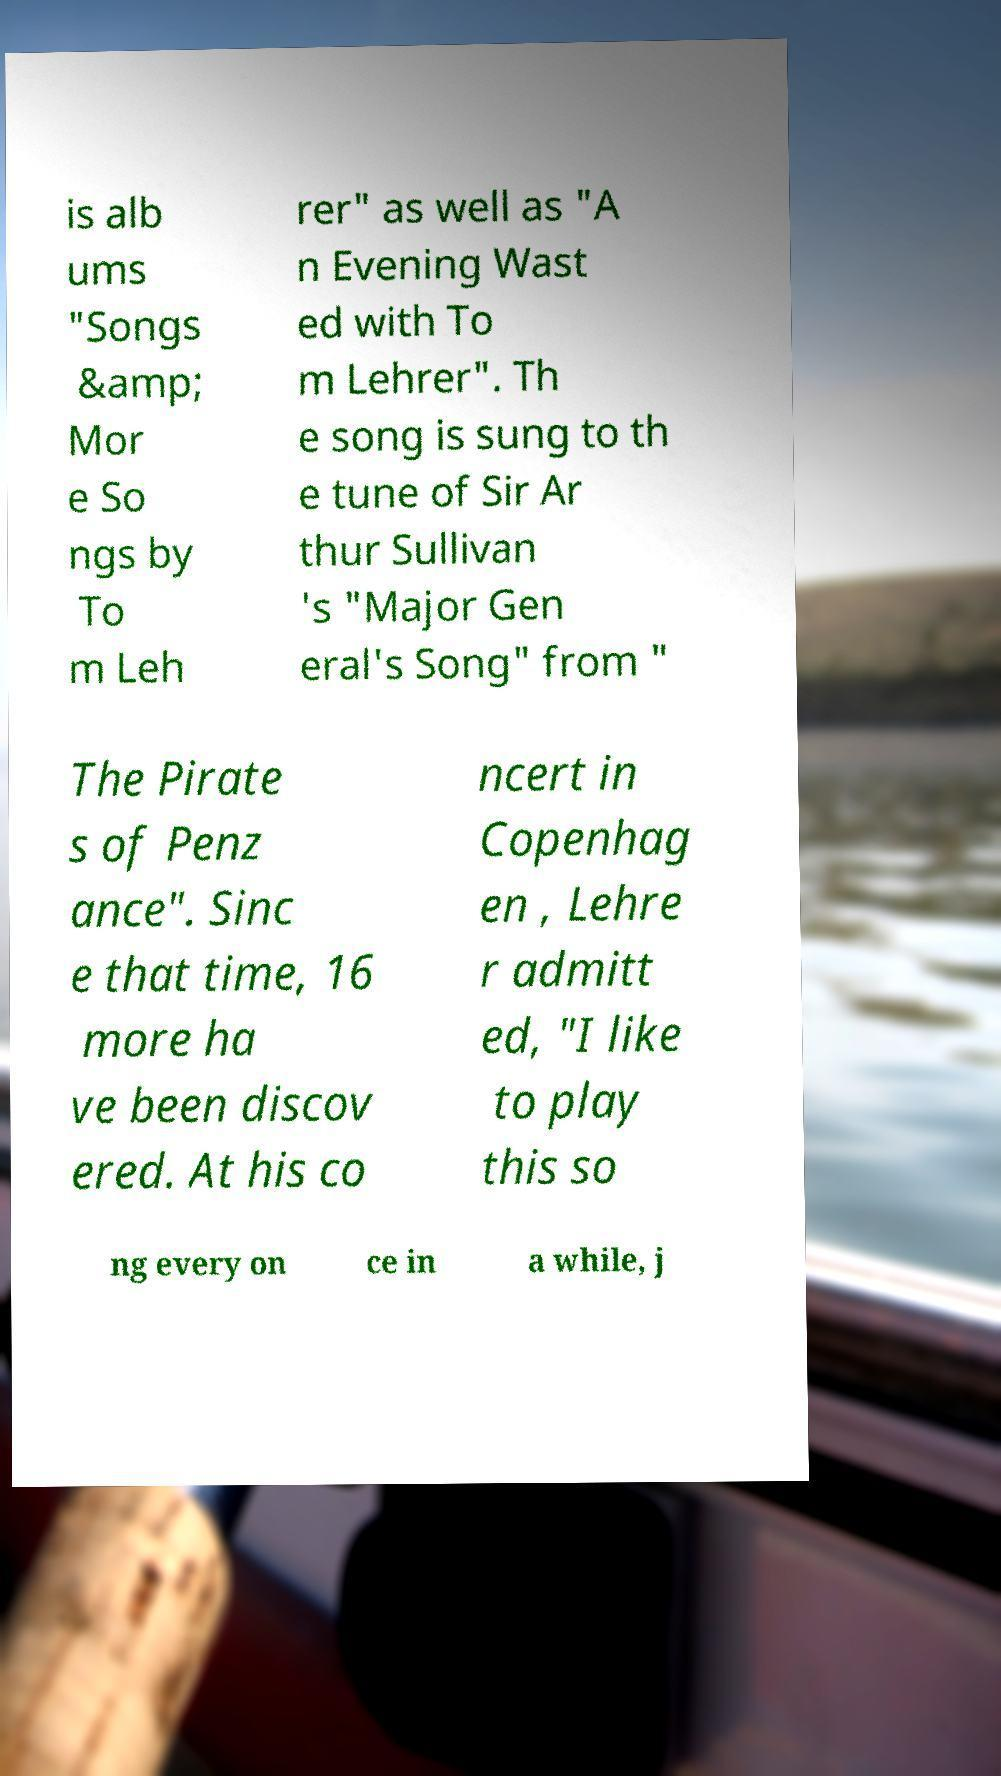I need the written content from this picture converted into text. Can you do that? is alb ums "Songs &amp; Mor e So ngs by To m Leh rer" as well as "A n Evening Wast ed with To m Lehrer". Th e song is sung to th e tune of Sir Ar thur Sullivan 's "Major Gen eral's Song" from " The Pirate s of Penz ance". Sinc e that time, 16 more ha ve been discov ered. At his co ncert in Copenhag en , Lehre r admitt ed, "I like to play this so ng every on ce in a while, j 